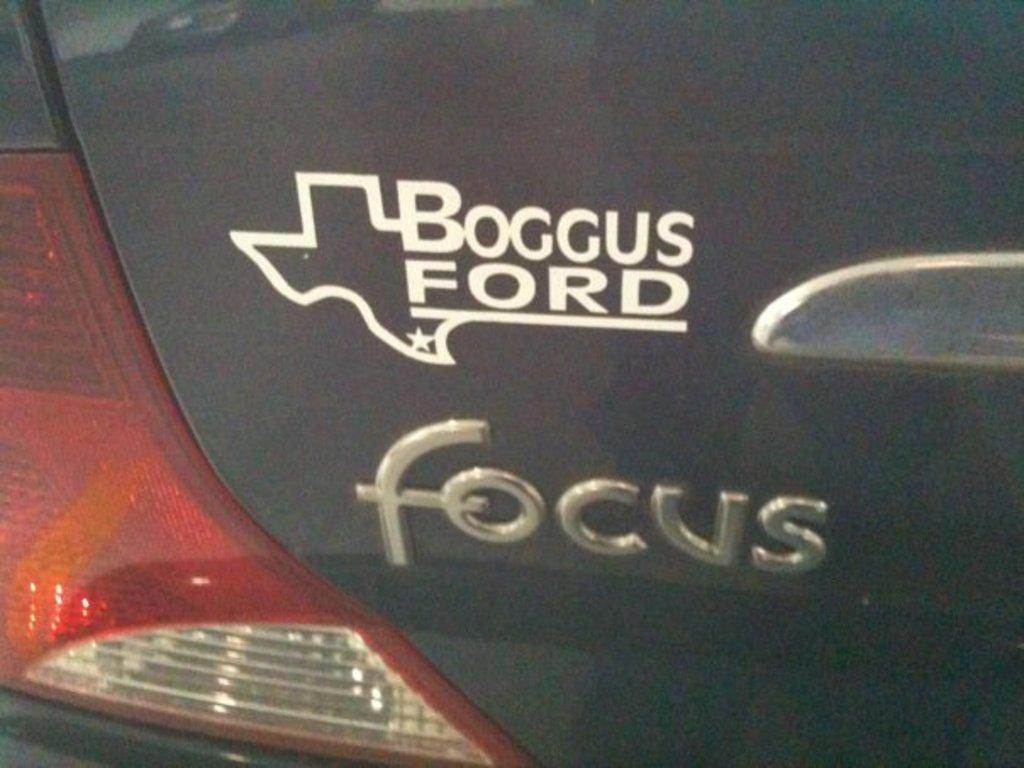What type of vehicle is in the image? There is a black car in the image. What is located in the center of the car? There is a sticker in the center of the car. What information can be found on the sticker? The company's name is visible on the sticker. What can be seen on the left side of the car? There is a light on the left side of the car. How many pizzas are being delivered by the car in the image? There is no indication of pizza delivery in the image; it only shows a black car with a sticker and a light. 